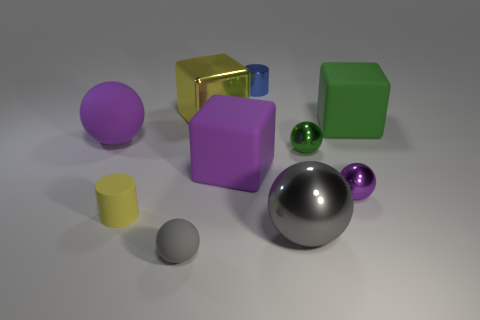Subtract 2 spheres. How many spheres are left? 3 Subtract all green balls. How many balls are left? 4 Subtract all big purple rubber spheres. How many spheres are left? 4 Subtract all cyan balls. Subtract all brown cylinders. How many balls are left? 5 Subtract 0 red cylinders. How many objects are left? 10 Subtract all cubes. How many objects are left? 7 Subtract all blue metallic balls. Subtract all blue cylinders. How many objects are left? 9 Add 2 tiny blue metal things. How many tiny blue metal things are left? 3 Add 7 tiny metallic cylinders. How many tiny metallic cylinders exist? 8 